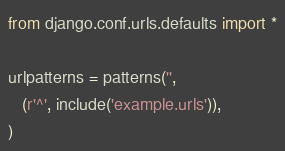Convert code to text. <code><loc_0><loc_0><loc_500><loc_500><_Python_>from django.conf.urls.defaults import *

urlpatterns = patterns('',
   (r'^', include('example.urls')),
)
</code> 